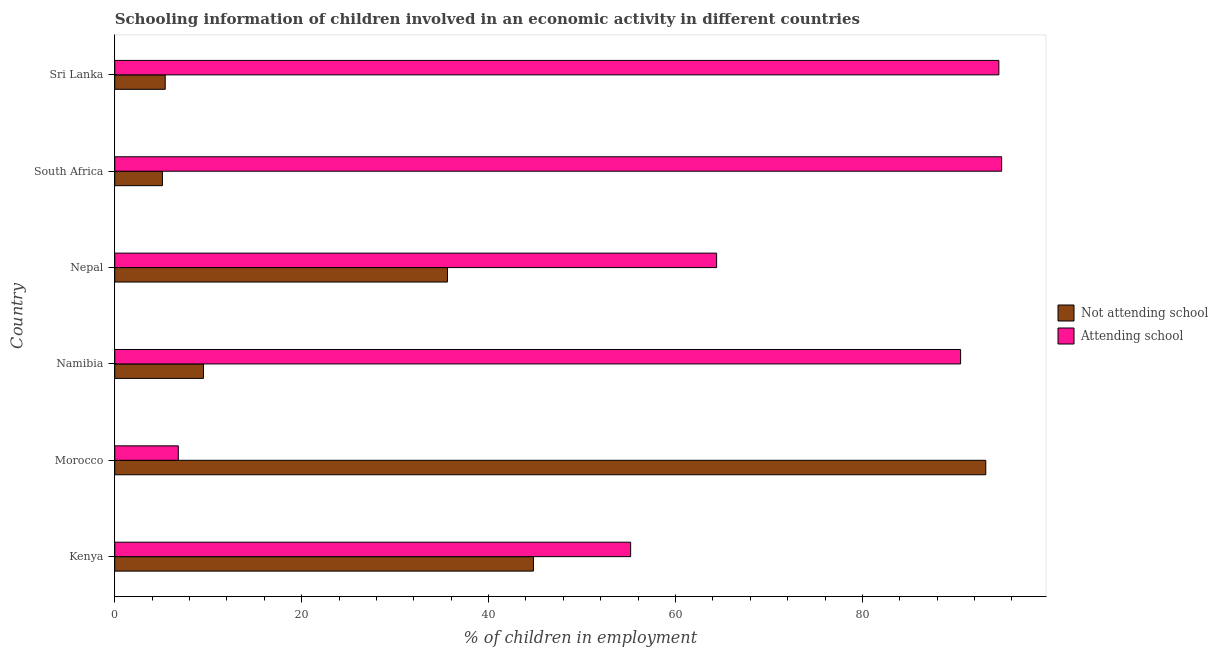Are the number of bars per tick equal to the number of legend labels?
Offer a terse response. Yes. What is the label of the 4th group of bars from the top?
Provide a succinct answer. Namibia. What is the percentage of employed children who are attending school in Morocco?
Offer a very short reply. 6.8. Across all countries, what is the maximum percentage of employed children who are not attending school?
Offer a very short reply. 93.2. Across all countries, what is the minimum percentage of employed children who are not attending school?
Ensure brevity in your answer.  5.1. In which country was the percentage of employed children who are not attending school maximum?
Make the answer very short. Morocco. In which country was the percentage of employed children who are not attending school minimum?
Your answer should be very brief. South Africa. What is the total percentage of employed children who are not attending school in the graph?
Your answer should be very brief. 193.59. What is the difference between the percentage of employed children who are attending school in Nepal and that in South Africa?
Offer a very short reply. -30.5. What is the average percentage of employed children who are not attending school per country?
Provide a short and direct response. 32.27. What is the difference between the percentage of employed children who are attending school and percentage of employed children who are not attending school in Nepal?
Give a very brief answer. 28.8. In how many countries, is the percentage of employed children who are attending school greater than 44 %?
Provide a short and direct response. 5. What is the ratio of the percentage of employed children who are attending school in Kenya to that in Namibia?
Make the answer very short. 0.61. Is the difference between the percentage of employed children who are not attending school in Morocco and Sri Lanka greater than the difference between the percentage of employed children who are attending school in Morocco and Sri Lanka?
Keep it short and to the point. Yes. What is the difference between the highest and the second highest percentage of employed children who are not attending school?
Provide a short and direct response. 48.4. What is the difference between the highest and the lowest percentage of employed children who are not attending school?
Your answer should be very brief. 88.1. In how many countries, is the percentage of employed children who are not attending school greater than the average percentage of employed children who are not attending school taken over all countries?
Offer a terse response. 3. Is the sum of the percentage of employed children who are attending school in South Africa and Sri Lanka greater than the maximum percentage of employed children who are not attending school across all countries?
Your response must be concise. Yes. What does the 2nd bar from the top in South Africa represents?
Provide a succinct answer. Not attending school. What does the 2nd bar from the bottom in Nepal represents?
Provide a short and direct response. Attending school. Are all the bars in the graph horizontal?
Your answer should be compact. Yes. How many countries are there in the graph?
Your answer should be compact. 6. What is the difference between two consecutive major ticks on the X-axis?
Provide a short and direct response. 20. Does the graph contain grids?
Your answer should be compact. No. What is the title of the graph?
Your answer should be very brief. Schooling information of children involved in an economic activity in different countries. What is the label or title of the X-axis?
Keep it short and to the point. % of children in employment. What is the label or title of the Y-axis?
Offer a very short reply. Country. What is the % of children in employment of Not attending school in Kenya?
Provide a short and direct response. 44.8. What is the % of children in employment of Attending school in Kenya?
Your answer should be very brief. 55.2. What is the % of children in employment in Not attending school in Morocco?
Your response must be concise. 93.2. What is the % of children in employment in Not attending school in Namibia?
Give a very brief answer. 9.49. What is the % of children in employment in Attending school in Namibia?
Provide a succinct answer. 90.51. What is the % of children in employment in Not attending school in Nepal?
Ensure brevity in your answer.  35.6. What is the % of children in employment in Attending school in Nepal?
Offer a very short reply. 64.4. What is the % of children in employment of Not attending school in South Africa?
Offer a very short reply. 5.1. What is the % of children in employment of Attending school in South Africa?
Offer a very short reply. 94.9. What is the % of children in employment of Attending school in Sri Lanka?
Your response must be concise. 94.6. Across all countries, what is the maximum % of children in employment in Not attending school?
Keep it short and to the point. 93.2. Across all countries, what is the maximum % of children in employment in Attending school?
Your answer should be very brief. 94.9. Across all countries, what is the minimum % of children in employment in Not attending school?
Provide a short and direct response. 5.1. What is the total % of children in employment of Not attending school in the graph?
Provide a short and direct response. 193.59. What is the total % of children in employment of Attending school in the graph?
Keep it short and to the point. 406.41. What is the difference between the % of children in employment in Not attending school in Kenya and that in Morocco?
Offer a terse response. -48.4. What is the difference between the % of children in employment in Attending school in Kenya and that in Morocco?
Your answer should be very brief. 48.4. What is the difference between the % of children in employment of Not attending school in Kenya and that in Namibia?
Offer a terse response. 35.31. What is the difference between the % of children in employment in Attending school in Kenya and that in Namibia?
Give a very brief answer. -35.31. What is the difference between the % of children in employment of Not attending school in Kenya and that in South Africa?
Offer a terse response. 39.7. What is the difference between the % of children in employment of Attending school in Kenya and that in South Africa?
Provide a succinct answer. -39.7. What is the difference between the % of children in employment of Not attending school in Kenya and that in Sri Lanka?
Give a very brief answer. 39.4. What is the difference between the % of children in employment in Attending school in Kenya and that in Sri Lanka?
Offer a terse response. -39.4. What is the difference between the % of children in employment of Not attending school in Morocco and that in Namibia?
Your response must be concise. 83.71. What is the difference between the % of children in employment in Attending school in Morocco and that in Namibia?
Your response must be concise. -83.71. What is the difference between the % of children in employment of Not attending school in Morocco and that in Nepal?
Provide a succinct answer. 57.6. What is the difference between the % of children in employment in Attending school in Morocco and that in Nepal?
Offer a terse response. -57.6. What is the difference between the % of children in employment of Not attending school in Morocco and that in South Africa?
Provide a succinct answer. 88.1. What is the difference between the % of children in employment in Attending school in Morocco and that in South Africa?
Your answer should be compact. -88.1. What is the difference between the % of children in employment of Not attending school in Morocco and that in Sri Lanka?
Give a very brief answer. 87.8. What is the difference between the % of children in employment of Attending school in Morocco and that in Sri Lanka?
Your answer should be compact. -87.8. What is the difference between the % of children in employment in Not attending school in Namibia and that in Nepal?
Give a very brief answer. -26.11. What is the difference between the % of children in employment of Attending school in Namibia and that in Nepal?
Ensure brevity in your answer.  26.11. What is the difference between the % of children in employment of Not attending school in Namibia and that in South Africa?
Offer a terse response. 4.39. What is the difference between the % of children in employment in Attending school in Namibia and that in South Africa?
Your answer should be very brief. -4.39. What is the difference between the % of children in employment of Not attending school in Namibia and that in Sri Lanka?
Your response must be concise. 4.09. What is the difference between the % of children in employment of Attending school in Namibia and that in Sri Lanka?
Make the answer very short. -4.09. What is the difference between the % of children in employment of Not attending school in Nepal and that in South Africa?
Your response must be concise. 30.5. What is the difference between the % of children in employment in Attending school in Nepal and that in South Africa?
Ensure brevity in your answer.  -30.5. What is the difference between the % of children in employment of Not attending school in Nepal and that in Sri Lanka?
Your answer should be compact. 30.2. What is the difference between the % of children in employment of Attending school in Nepal and that in Sri Lanka?
Your answer should be compact. -30.2. What is the difference between the % of children in employment in Not attending school in Kenya and the % of children in employment in Attending school in Morocco?
Your response must be concise. 38. What is the difference between the % of children in employment of Not attending school in Kenya and the % of children in employment of Attending school in Namibia?
Give a very brief answer. -45.71. What is the difference between the % of children in employment of Not attending school in Kenya and the % of children in employment of Attending school in Nepal?
Provide a short and direct response. -19.6. What is the difference between the % of children in employment of Not attending school in Kenya and the % of children in employment of Attending school in South Africa?
Ensure brevity in your answer.  -50.1. What is the difference between the % of children in employment of Not attending school in Kenya and the % of children in employment of Attending school in Sri Lanka?
Make the answer very short. -49.8. What is the difference between the % of children in employment of Not attending school in Morocco and the % of children in employment of Attending school in Namibia?
Keep it short and to the point. 2.69. What is the difference between the % of children in employment in Not attending school in Morocco and the % of children in employment in Attending school in Nepal?
Provide a succinct answer. 28.8. What is the difference between the % of children in employment in Not attending school in Namibia and the % of children in employment in Attending school in Nepal?
Your answer should be compact. -54.91. What is the difference between the % of children in employment in Not attending school in Namibia and the % of children in employment in Attending school in South Africa?
Provide a short and direct response. -85.41. What is the difference between the % of children in employment in Not attending school in Namibia and the % of children in employment in Attending school in Sri Lanka?
Give a very brief answer. -85.11. What is the difference between the % of children in employment of Not attending school in Nepal and the % of children in employment of Attending school in South Africa?
Your answer should be very brief. -59.3. What is the difference between the % of children in employment of Not attending school in Nepal and the % of children in employment of Attending school in Sri Lanka?
Ensure brevity in your answer.  -59. What is the difference between the % of children in employment of Not attending school in South Africa and the % of children in employment of Attending school in Sri Lanka?
Your response must be concise. -89.5. What is the average % of children in employment in Not attending school per country?
Your answer should be very brief. 32.27. What is the average % of children in employment of Attending school per country?
Your response must be concise. 67.73. What is the difference between the % of children in employment of Not attending school and % of children in employment of Attending school in Kenya?
Offer a terse response. -10.4. What is the difference between the % of children in employment in Not attending school and % of children in employment in Attending school in Morocco?
Ensure brevity in your answer.  86.4. What is the difference between the % of children in employment of Not attending school and % of children in employment of Attending school in Namibia?
Provide a succinct answer. -81.01. What is the difference between the % of children in employment in Not attending school and % of children in employment in Attending school in Nepal?
Give a very brief answer. -28.8. What is the difference between the % of children in employment of Not attending school and % of children in employment of Attending school in South Africa?
Keep it short and to the point. -89.8. What is the difference between the % of children in employment of Not attending school and % of children in employment of Attending school in Sri Lanka?
Offer a very short reply. -89.2. What is the ratio of the % of children in employment of Not attending school in Kenya to that in Morocco?
Offer a very short reply. 0.48. What is the ratio of the % of children in employment of Attending school in Kenya to that in Morocco?
Make the answer very short. 8.12. What is the ratio of the % of children in employment in Not attending school in Kenya to that in Namibia?
Ensure brevity in your answer.  4.72. What is the ratio of the % of children in employment of Attending school in Kenya to that in Namibia?
Give a very brief answer. 0.61. What is the ratio of the % of children in employment of Not attending school in Kenya to that in Nepal?
Offer a terse response. 1.26. What is the ratio of the % of children in employment in Attending school in Kenya to that in Nepal?
Provide a succinct answer. 0.86. What is the ratio of the % of children in employment in Not attending school in Kenya to that in South Africa?
Provide a succinct answer. 8.78. What is the ratio of the % of children in employment in Attending school in Kenya to that in South Africa?
Keep it short and to the point. 0.58. What is the ratio of the % of children in employment in Not attending school in Kenya to that in Sri Lanka?
Offer a terse response. 8.3. What is the ratio of the % of children in employment of Attending school in Kenya to that in Sri Lanka?
Ensure brevity in your answer.  0.58. What is the ratio of the % of children in employment of Not attending school in Morocco to that in Namibia?
Give a very brief answer. 9.82. What is the ratio of the % of children in employment of Attending school in Morocco to that in Namibia?
Offer a terse response. 0.08. What is the ratio of the % of children in employment in Not attending school in Morocco to that in Nepal?
Give a very brief answer. 2.62. What is the ratio of the % of children in employment in Attending school in Morocco to that in Nepal?
Provide a succinct answer. 0.11. What is the ratio of the % of children in employment in Not attending school in Morocco to that in South Africa?
Provide a succinct answer. 18.27. What is the ratio of the % of children in employment of Attending school in Morocco to that in South Africa?
Offer a very short reply. 0.07. What is the ratio of the % of children in employment in Not attending school in Morocco to that in Sri Lanka?
Offer a very short reply. 17.26. What is the ratio of the % of children in employment of Attending school in Morocco to that in Sri Lanka?
Make the answer very short. 0.07. What is the ratio of the % of children in employment of Not attending school in Namibia to that in Nepal?
Your answer should be very brief. 0.27. What is the ratio of the % of children in employment in Attending school in Namibia to that in Nepal?
Offer a terse response. 1.41. What is the ratio of the % of children in employment of Not attending school in Namibia to that in South Africa?
Offer a terse response. 1.86. What is the ratio of the % of children in employment in Attending school in Namibia to that in South Africa?
Make the answer very short. 0.95. What is the ratio of the % of children in employment of Not attending school in Namibia to that in Sri Lanka?
Ensure brevity in your answer.  1.76. What is the ratio of the % of children in employment in Attending school in Namibia to that in Sri Lanka?
Keep it short and to the point. 0.96. What is the ratio of the % of children in employment of Not attending school in Nepal to that in South Africa?
Give a very brief answer. 6.98. What is the ratio of the % of children in employment of Attending school in Nepal to that in South Africa?
Provide a succinct answer. 0.68. What is the ratio of the % of children in employment of Not attending school in Nepal to that in Sri Lanka?
Provide a succinct answer. 6.59. What is the ratio of the % of children in employment in Attending school in Nepal to that in Sri Lanka?
Make the answer very short. 0.68. What is the difference between the highest and the second highest % of children in employment of Not attending school?
Give a very brief answer. 48.4. What is the difference between the highest and the lowest % of children in employment of Not attending school?
Make the answer very short. 88.1. What is the difference between the highest and the lowest % of children in employment of Attending school?
Your answer should be very brief. 88.1. 